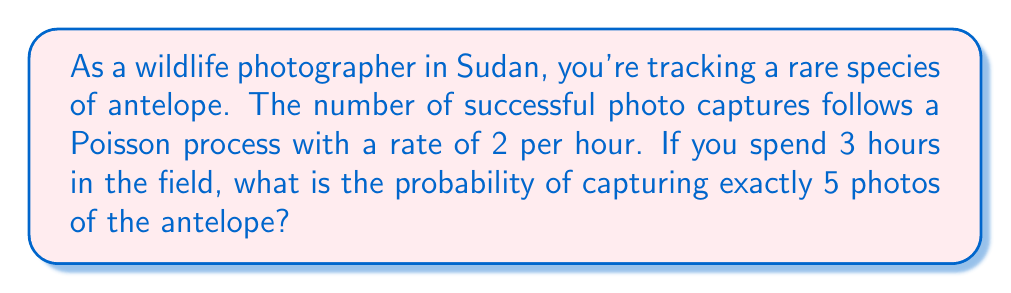Solve this math problem. Let's approach this step-by-step using the Poisson distribution:

1) The Poisson distribution is given by the formula:

   $$P(X = k) = \frac{e^{-\lambda} \lambda^k}{k!}$$

   where:
   - $\lambda$ is the average rate of events
   - $k$ is the number of events we're interested in
   - $e$ is Euler's number (approximately 2.71828)

2) In this case:
   - $\lambda = 2$ photos/hour * 3 hours = 6$ photos
   - $k = 5$ photos

3) Plugging these values into the formula:

   $$P(X = 5) = \frac{e^{-6} 6^5}{5!}$$

4) Let's calculate this step-by-step:
   
   a) First, $e^{-6} \approx 0.00248$
   
   b) $6^5 = 7776$
   
   c) $5! = 5 * 4 * 3 * 2 * 1 = 120$

5) Now, let's put it all together:

   $$P(X = 5) = \frac{0.00248 * 7776}{120} \approx 0.1606$$

6) Converting to a percentage:

   $0.1606 * 100\% \approx 16.06\%$

Therefore, the probability of capturing exactly 5 photos of the antelope in 3 hours is approximately 16.06%.
Answer: 16.06% 